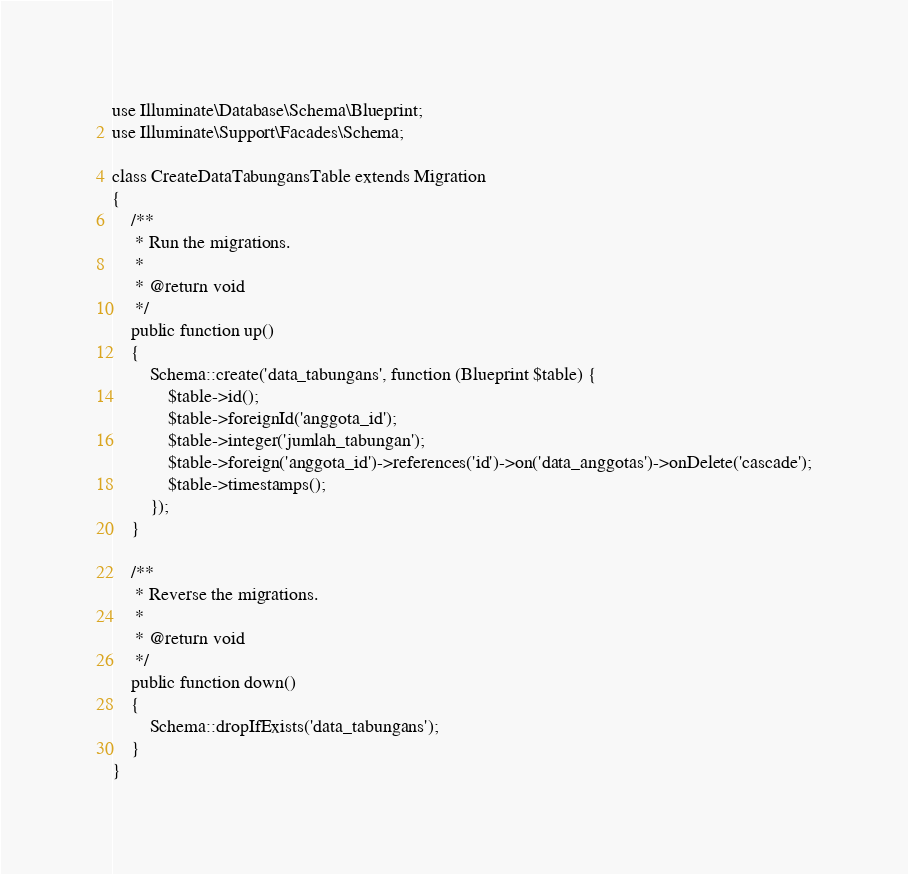<code> <loc_0><loc_0><loc_500><loc_500><_PHP_>use Illuminate\Database\Schema\Blueprint;
use Illuminate\Support\Facades\Schema;

class CreateDataTabungansTable extends Migration
{
    /**
     * Run the migrations.
     *
     * @return void
     */
    public function up()
    {
        Schema::create('data_tabungans', function (Blueprint $table) {
            $table->id();
            $table->foreignId('anggota_id');
            $table->integer('jumlah_tabungan');
            $table->foreign('anggota_id')->references('id')->on('data_anggotas')->onDelete('cascade');
            $table->timestamps();
        });
    }

    /**
     * Reverse the migrations.
     *
     * @return void
     */
    public function down()
    {
        Schema::dropIfExists('data_tabungans');
    }
}</code> 